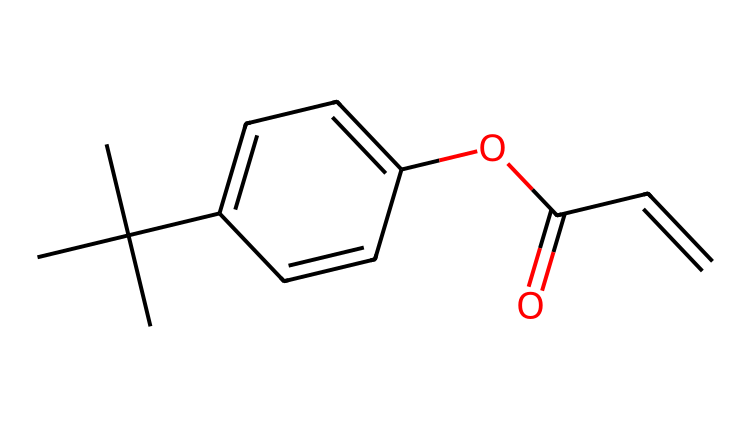What is the total number of carbon atoms in this photoresist? By examining the SMILES representation, each "C" denotes a carbon atom. The molecule has a branched structure, with 10 carbon atoms identified throughout the entire compound.
Answer: 10 How many aromatic rings are present in the chemical structure? Looking at the connections in the structure, there is one distinct aromatic ring present, which can be deduced from the alternating double bonds in the benzene-like part of the structure.
Answer: 1 What functional group is present in this photoresist? The presence of "OC(=O)" in the SMILES indicates the presence of an ester functional group, which is identified by the carbonyl and alkoxy components.
Answer: ester What is the degree of unsaturation in this chemical? The molecular structure includes several double bonds, which contribute to its degree of unsaturation. In this case, by counting rings and double bonds, the total degree of unsaturation can be calculated as 5.
Answer: 5 Does this chemical contain any heteroatoms? Upon inspecting the SMILES string, there are no nitrogen, oxygen, sulfur, or other heteroatoms present in this structure, confirming that all atoms are carbon and hydrogen.
Answer: no What is the overall classification of this chemical? Given the structure's characteristics, it is classified as a photoresist, which is designed for light-sensitive applications in developing photographs, as indicated by the chemical properties inferred from the structure.
Answer: photoresist 